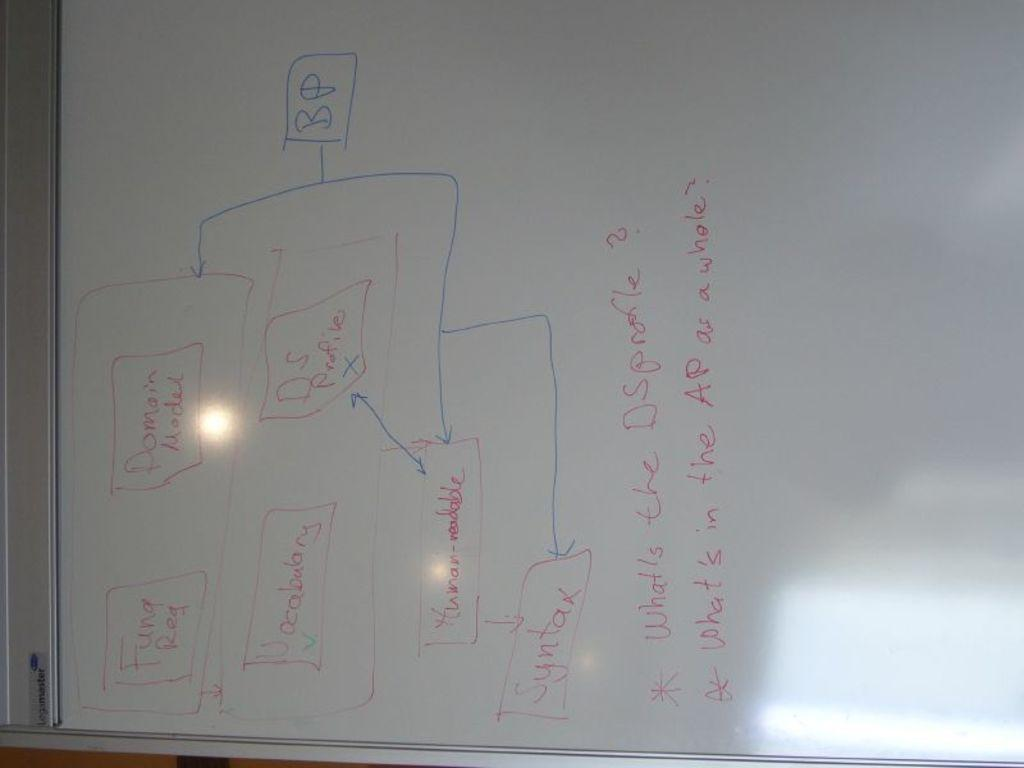<image>
Summarize the visual content of the image. A diagram on a whiteboard says "BP" in the box at the top. 